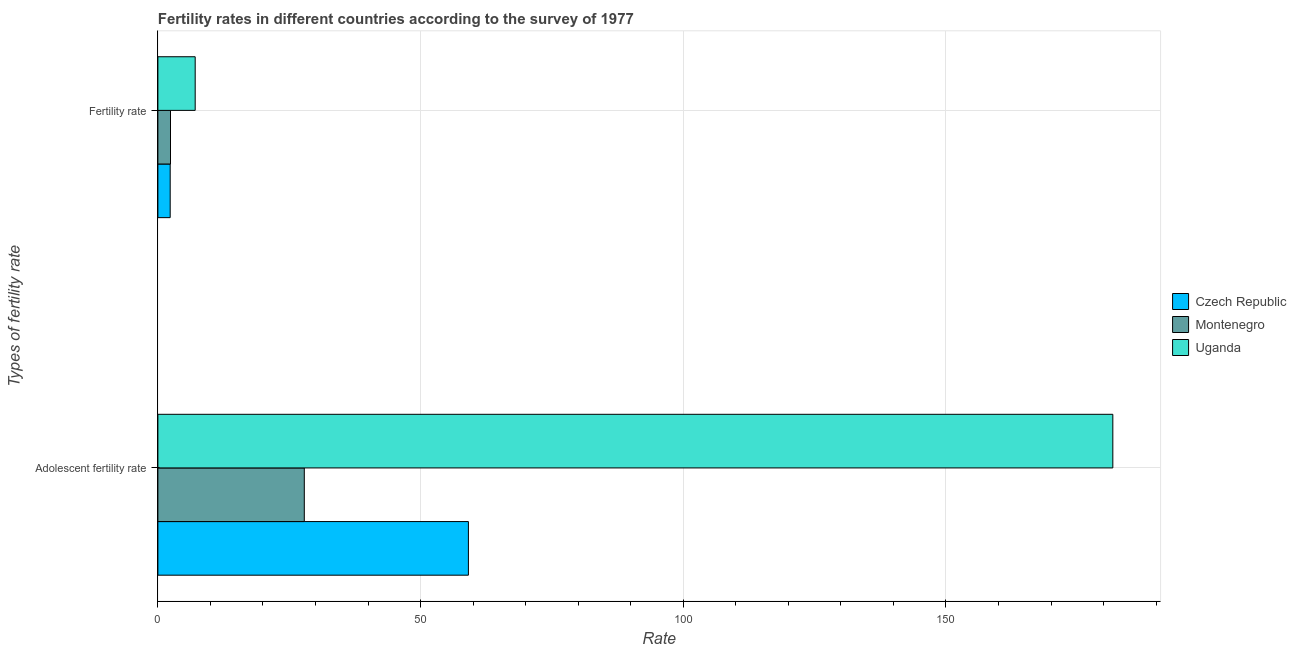How many different coloured bars are there?
Your response must be concise. 3. How many groups of bars are there?
Your response must be concise. 2. How many bars are there on the 1st tick from the bottom?
Offer a terse response. 3. What is the label of the 2nd group of bars from the top?
Ensure brevity in your answer.  Adolescent fertility rate. What is the adolescent fertility rate in Montenegro?
Your response must be concise. 27.87. Across all countries, what is the maximum fertility rate?
Keep it short and to the point. 7.1. Across all countries, what is the minimum adolescent fertility rate?
Keep it short and to the point. 27.87. In which country was the fertility rate maximum?
Keep it short and to the point. Uganda. In which country was the adolescent fertility rate minimum?
Your answer should be compact. Montenegro. What is the total adolescent fertility rate in the graph?
Offer a very short reply. 268.73. What is the difference between the fertility rate in Montenegro and that in Czech Republic?
Provide a succinct answer. 0.06. What is the difference between the adolescent fertility rate in Montenegro and the fertility rate in Czech Republic?
Your answer should be very brief. 25.53. What is the average fertility rate per country?
Give a very brief answer. 3.95. What is the difference between the fertility rate and adolescent fertility rate in Uganda?
Your response must be concise. -174.66. What is the ratio of the adolescent fertility rate in Uganda to that in Montenegro?
Make the answer very short. 6.52. What does the 2nd bar from the top in Fertility rate represents?
Keep it short and to the point. Montenegro. What does the 2nd bar from the bottom in Adolescent fertility rate represents?
Ensure brevity in your answer.  Montenegro. How many bars are there?
Make the answer very short. 6. What is the difference between two consecutive major ticks on the X-axis?
Your response must be concise. 50. Are the values on the major ticks of X-axis written in scientific E-notation?
Give a very brief answer. No. Does the graph contain any zero values?
Your answer should be compact. No. Does the graph contain grids?
Provide a succinct answer. Yes. How many legend labels are there?
Keep it short and to the point. 3. What is the title of the graph?
Offer a terse response. Fertility rates in different countries according to the survey of 1977. What is the label or title of the X-axis?
Offer a terse response. Rate. What is the label or title of the Y-axis?
Your response must be concise. Types of fertility rate. What is the Rate of Czech Republic in Adolescent fertility rate?
Make the answer very short. 59.1. What is the Rate in Montenegro in Adolescent fertility rate?
Make the answer very short. 27.87. What is the Rate in Uganda in Adolescent fertility rate?
Ensure brevity in your answer.  181.76. What is the Rate in Czech Republic in Fertility rate?
Your response must be concise. 2.34. What is the Rate of Montenegro in Fertility rate?
Make the answer very short. 2.4. What is the Rate of Uganda in Fertility rate?
Your response must be concise. 7.1. Across all Types of fertility rate, what is the maximum Rate in Czech Republic?
Make the answer very short. 59.1. Across all Types of fertility rate, what is the maximum Rate in Montenegro?
Ensure brevity in your answer.  27.87. Across all Types of fertility rate, what is the maximum Rate in Uganda?
Your answer should be very brief. 181.76. Across all Types of fertility rate, what is the minimum Rate in Czech Republic?
Offer a very short reply. 2.34. Across all Types of fertility rate, what is the minimum Rate in Montenegro?
Your answer should be compact. 2.4. Across all Types of fertility rate, what is the minimum Rate in Uganda?
Offer a terse response. 7.1. What is the total Rate in Czech Republic in the graph?
Ensure brevity in your answer.  61.44. What is the total Rate in Montenegro in the graph?
Make the answer very short. 30.27. What is the total Rate of Uganda in the graph?
Offer a terse response. 188.86. What is the difference between the Rate of Czech Republic in Adolescent fertility rate and that in Fertility rate?
Make the answer very short. 56.76. What is the difference between the Rate of Montenegro in Adolescent fertility rate and that in Fertility rate?
Provide a short and direct response. 25.46. What is the difference between the Rate in Uganda in Adolescent fertility rate and that in Fertility rate?
Ensure brevity in your answer.  174.66. What is the difference between the Rate in Czech Republic in Adolescent fertility rate and the Rate in Montenegro in Fertility rate?
Provide a short and direct response. 56.7. What is the difference between the Rate of Czech Republic in Adolescent fertility rate and the Rate of Uganda in Fertility rate?
Offer a terse response. 52. What is the difference between the Rate of Montenegro in Adolescent fertility rate and the Rate of Uganda in Fertility rate?
Ensure brevity in your answer.  20.77. What is the average Rate of Czech Republic per Types of fertility rate?
Offer a terse response. 30.72. What is the average Rate of Montenegro per Types of fertility rate?
Give a very brief answer. 15.13. What is the average Rate of Uganda per Types of fertility rate?
Make the answer very short. 94.43. What is the difference between the Rate in Czech Republic and Rate in Montenegro in Adolescent fertility rate?
Provide a short and direct response. 31.24. What is the difference between the Rate of Czech Republic and Rate of Uganda in Adolescent fertility rate?
Ensure brevity in your answer.  -122.66. What is the difference between the Rate in Montenegro and Rate in Uganda in Adolescent fertility rate?
Your response must be concise. -153.89. What is the difference between the Rate in Czech Republic and Rate in Montenegro in Fertility rate?
Your response must be concise. -0.06. What is the difference between the Rate in Czech Republic and Rate in Uganda in Fertility rate?
Make the answer very short. -4.76. What is the difference between the Rate of Montenegro and Rate of Uganda in Fertility rate?
Give a very brief answer. -4.7. What is the ratio of the Rate in Czech Republic in Adolescent fertility rate to that in Fertility rate?
Offer a terse response. 25.26. What is the ratio of the Rate in Montenegro in Adolescent fertility rate to that in Fertility rate?
Offer a terse response. 11.6. What is the ratio of the Rate in Uganda in Adolescent fertility rate to that in Fertility rate?
Give a very brief answer. 25.6. What is the difference between the highest and the second highest Rate of Czech Republic?
Your answer should be compact. 56.76. What is the difference between the highest and the second highest Rate of Montenegro?
Your answer should be compact. 25.46. What is the difference between the highest and the second highest Rate in Uganda?
Provide a short and direct response. 174.66. What is the difference between the highest and the lowest Rate of Czech Republic?
Provide a succinct answer. 56.76. What is the difference between the highest and the lowest Rate in Montenegro?
Your answer should be compact. 25.46. What is the difference between the highest and the lowest Rate of Uganda?
Your answer should be very brief. 174.66. 